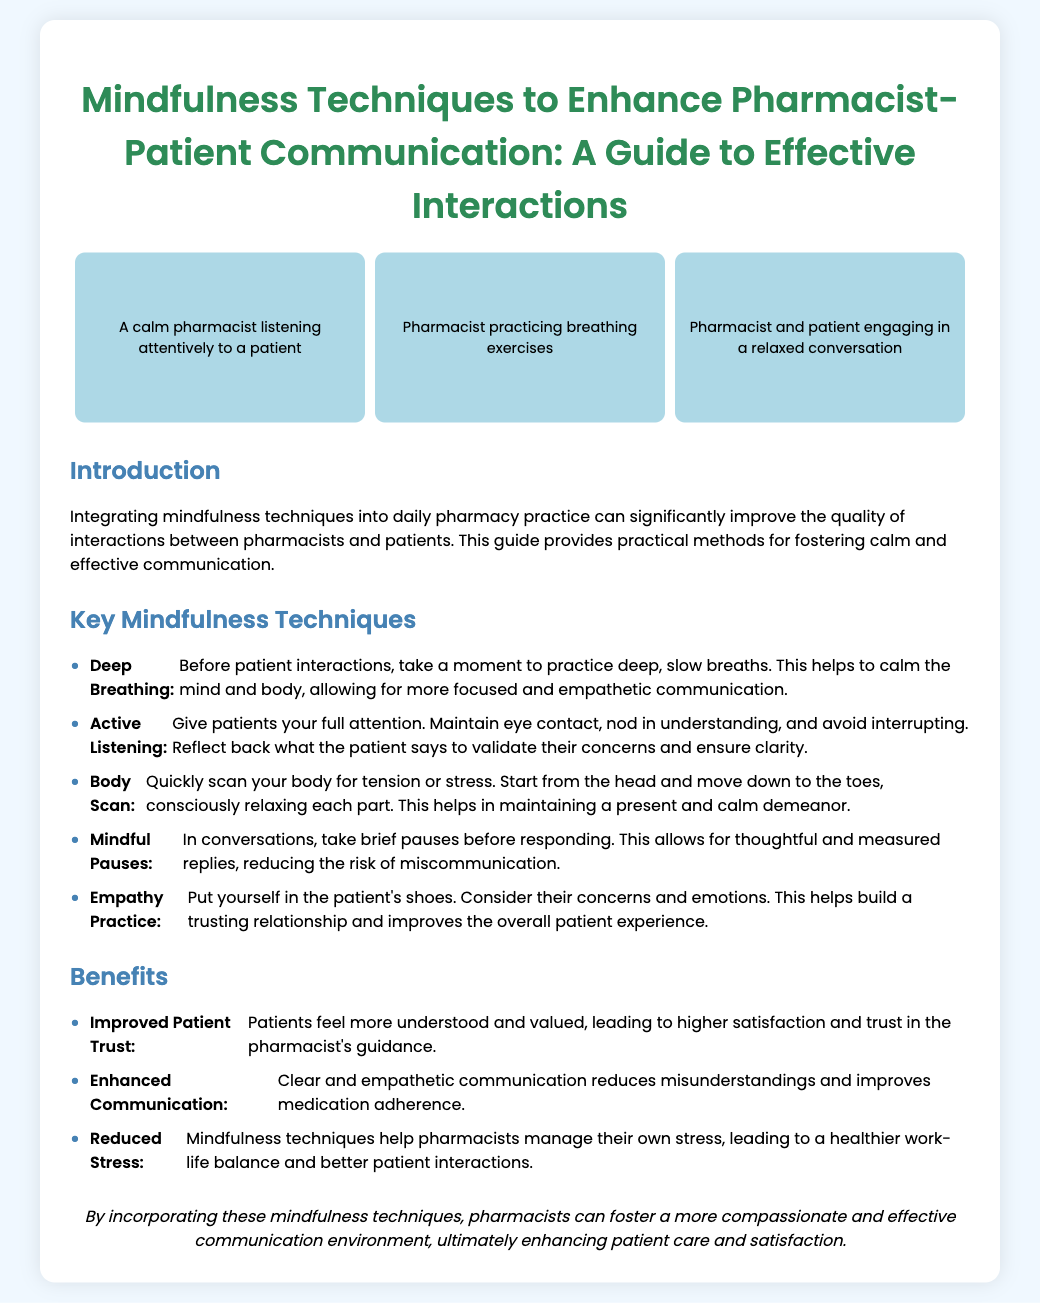What is the title of the poster? The title is prominently displayed at the top of the document, stating the main topic.
Answer: Mindfulness Techniques to Enhance Pharmacist-Patient Communication: A Guide to Effective Interactions How many key mindfulness techniques are listed? The document presents a section titled "Key Mindfulness Techniques" that contains a bulleted list.
Answer: Five What technique involves taking slow breaths before interactions? The document specifies techniques for calming the mind and body before patient encounters.
Answer: Deep Breathing Which illustration depicts a pharmacist practicing breathing exercises? The illustrations are named in the context of their activities.
Answer: Pharmacist practicing breathing exercises What benefit is related to improved patient relationships? The benefits section details outcomes of incorporating mindfulness techniques.
Answer: Improved Patient Trust What is the main goal of incorporating mindfulness in pharmacy practice? The poster explains the purpose of integrating mindfulness in pharmacist-patient interactions.
Answer: Enhancing patient care and satisfaction What type of pause is suggested during conversations? The document suggests a specific practice to improve communication.
Answer: Mindful Pauses What color is used for the main title text? The styling section of the document indicates how the title is colored.
Answer: #2E8B57 